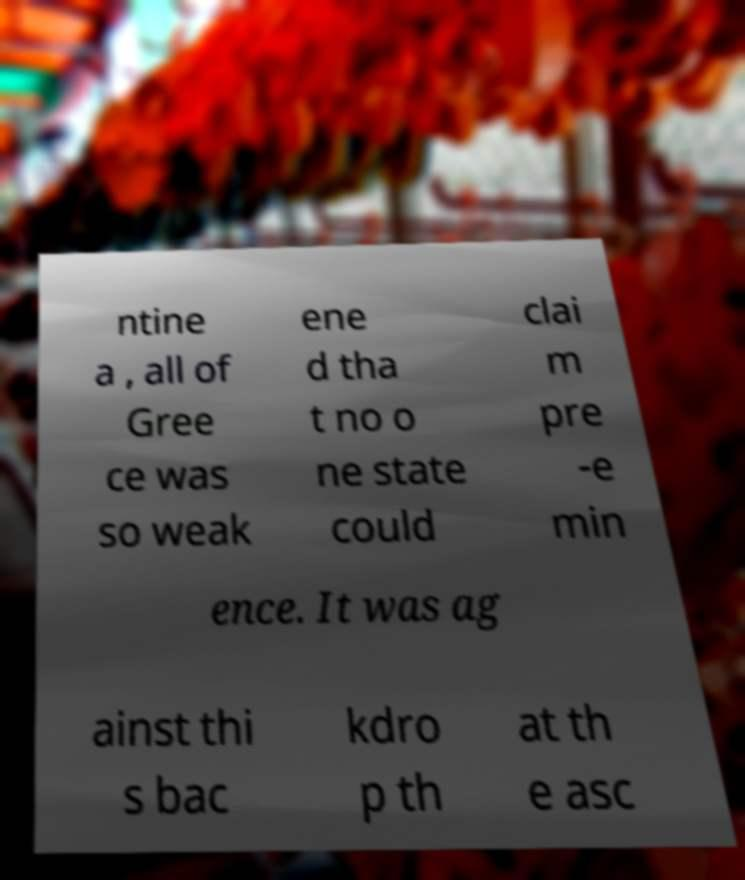What messages or text are displayed in this image? I need them in a readable, typed format. ntine a , all of Gree ce was so weak ene d tha t no o ne state could clai m pre -e min ence. It was ag ainst thi s bac kdro p th at th e asc 